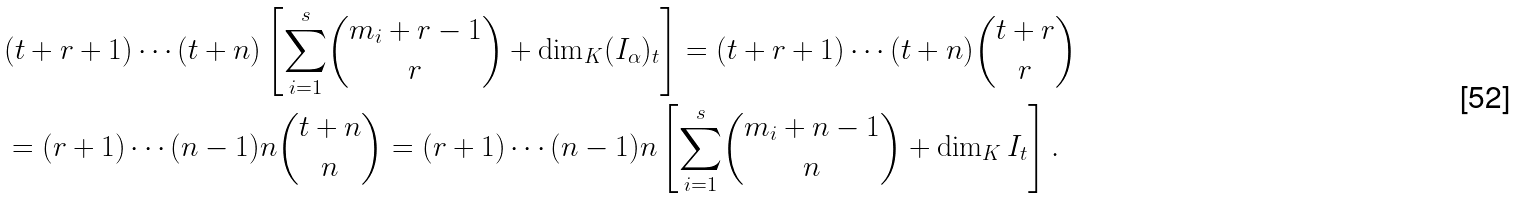<formula> <loc_0><loc_0><loc_500><loc_500>& ( t + r + 1 ) \cdots ( t + n ) \left [ \underset { i = 1 } { \overset { s } { \sum } } \binom { m _ { i } + r - 1 } { r } + \dim _ { K } ( I _ { \alpha } ) _ { t } \right ] = ( t + r + 1 ) \cdots ( t + n ) \binom { t + r } { r } \\ & = ( r + 1 ) \cdots ( n - 1 ) n \binom { t + n } { n } = ( r + 1 ) \cdots ( n - 1 ) n \left [ \underset { i = 1 } { \overset { s } { \sum } } \binom { m _ { i } + n - 1 } { n } + \dim _ { K } I _ { t } \right ] .</formula> 